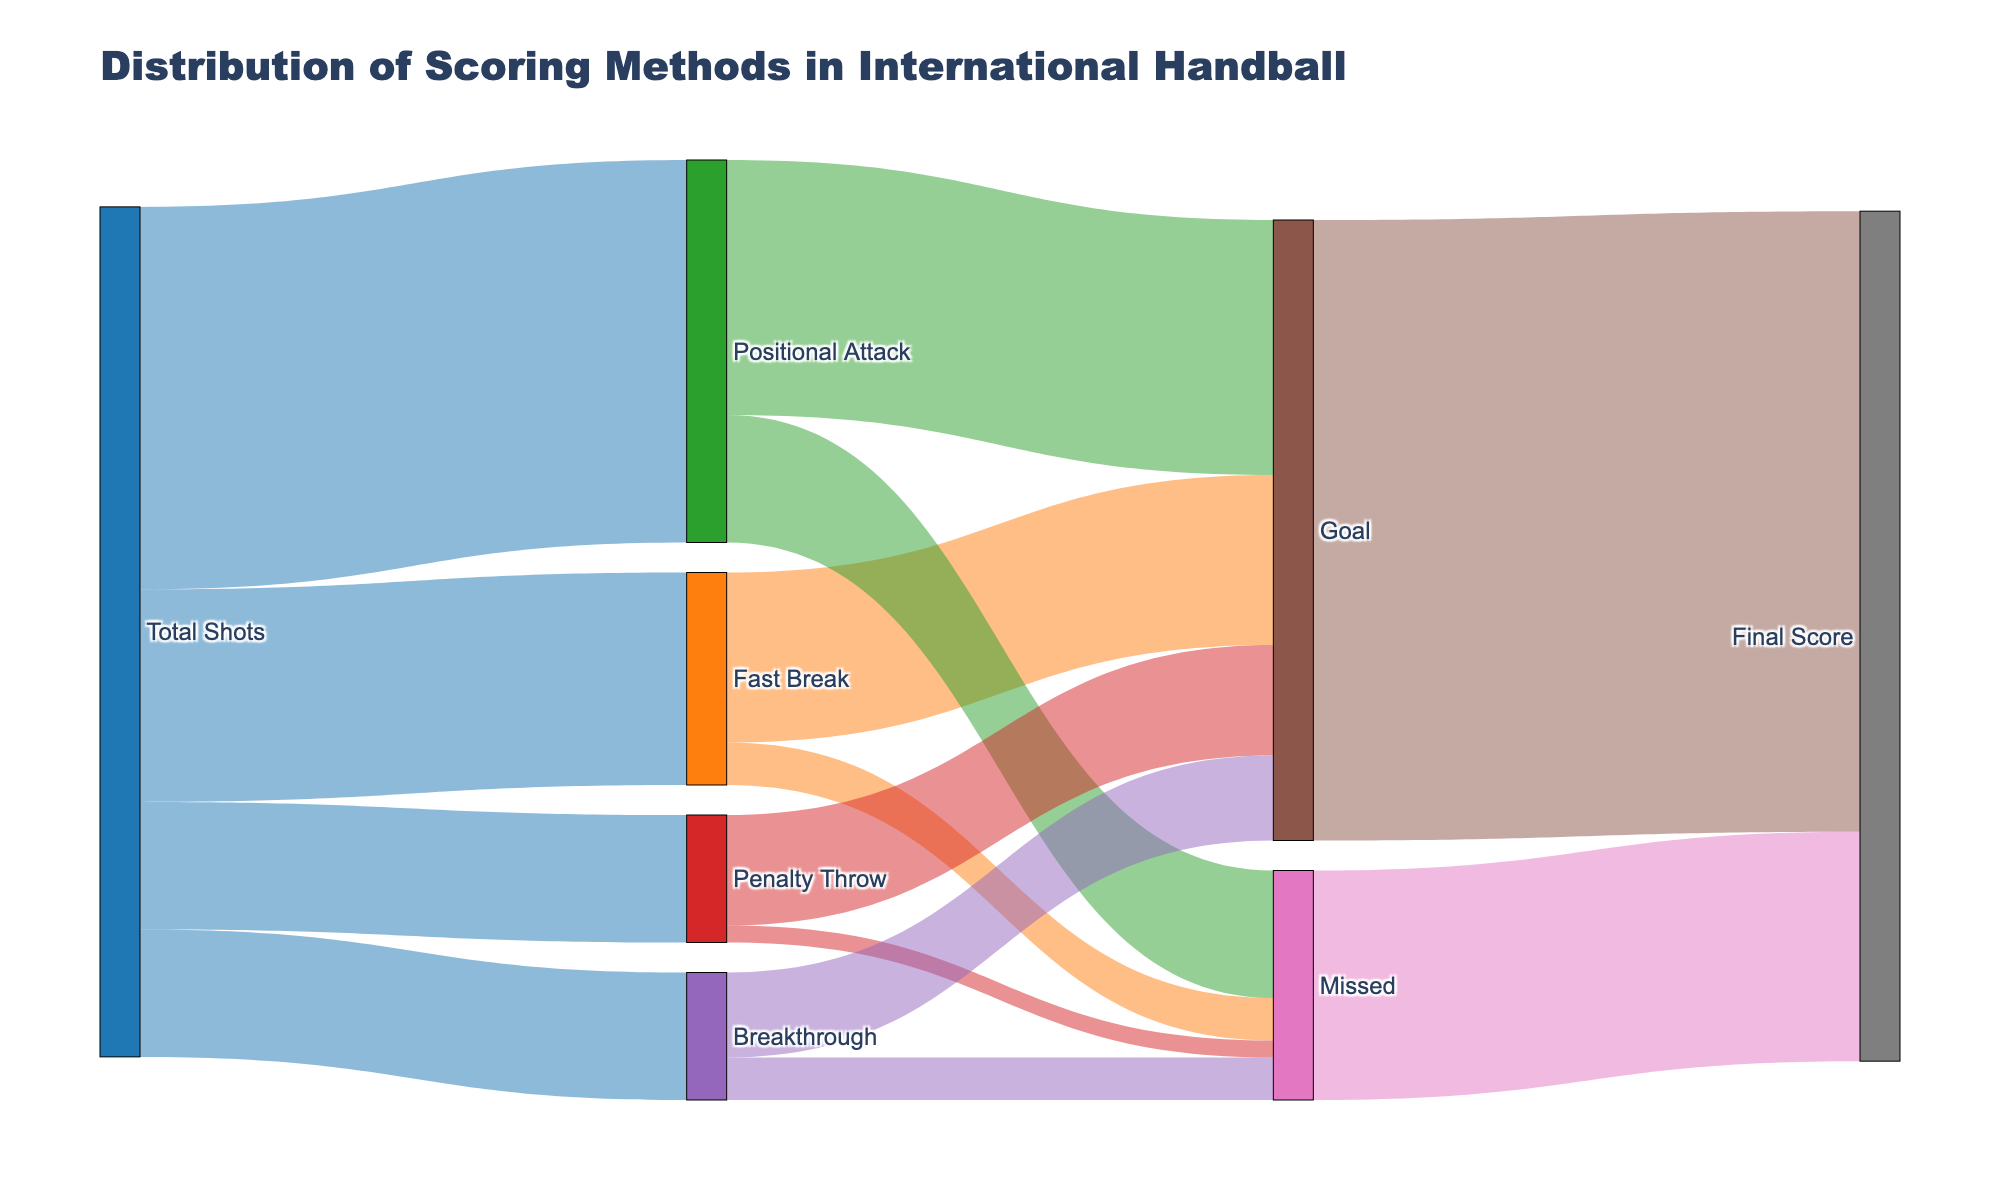What's the title of the figure? The title is usually located at the top of a figure and gives an overview of what the figure represents. In this case, the title is "Distribution of Scoring Methods in International Handball".
Answer: Distribution of Scoring Methods in International Handball How many total shots were taken? The figure indicates the total number of shots at the initial step in the Sankey Diagram, represented by the flow from the "Total Shots" node to each type of scoring method. According to the data, the total shots are the sum of Fast Break, Positional Attack, Penalty Throw, and Breakthrough: 25 + 45 + 15 + 15 = 100.
Answer: 100 What scoring method has the highest number of goals? To find the scoring method with the highest number of goals, refer to the nodes "Fast Break", "Positional Attack", "Penalty Throw", and "Breakthrough" and note the flow connecting these nodes to the "Goal" node. Positional Attack has 30 goals, which is the highest.
Answer: Positional Attack How many penalty throws did not result in a goal? Look at the connection between the "Penalty Throw" node and the "Missed" node, indicating the number of missed penalty throws. There are 2 missed penalty throws.
Answer: 2 Which scoring method contributes the least to the missed attempts? Compare the flows from each method ("Fast Break", "Positional Attack", "Penalty Throw", and "Breakthrough") to the "Missed" node. "Penalty Throw" contributes the least with 2 missed attempts.
Answer: Penalty Throw What percentage of total shots are positional attacks? The total shots are 100, and the number of positional attacks is 45. To find the percentage: (45 / 100) * 100 = 45%.
Answer: 45% How many goals were scored from breakthroughs? Look at the connection from "Breakthrough" to "Goal". The number of goals scored from breakthroughs is 10.
Answer: 10 What is the combined total of missed attempts from both positional attacks and breakthroughs? Identify the number of missed attempts from "Positional Attack" and "Breakthrough". Positional Attack has 15 missed attempts, and Breakthrough has 5. Adding them together gives 15 + 5 = 20.
Answer: 20 What proportion of goals come from fast breaks compared to total goals? The total goals are 73. The number of goals from fast breaks is 20. To find the proportion: (20 / 73) * 100 = approximately 27.4%.
Answer: 27.4% 